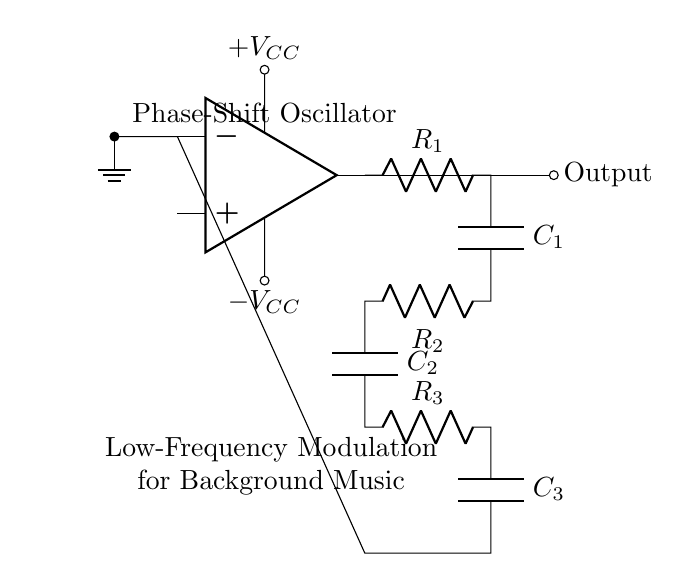What type of oscillator is presented in the circuit? The circuit is labeled as a Phase-Shift Oscillator, which is specifically designed for generating low-frequency waveforms.
Answer: Phase-Shift Oscillator What is the purpose of this oscillator circuit? The circuit is designed for low-frequency modulation in background music tracks, as indicated by the label below the op-amp.
Answer: Low-Frequency Modulation How many resistors are present in the feedback network? By counting the resistors in the circuit, there are three resistors labeled R1, R2, and R3 within the feedback network.
Answer: Three What is the function of the capacitors in the circuit? The capacitors create the phase shift necessary for oscillation in combination with the resistors, which is essential for the feedback loop of the oscillator.
Answer: Phase Shift What does the voltage supply indication suggest about the circuit's operation? The presence of positive and negative voltage supply labels indicates that the op-amp in the oscillator requires dual power supply for proper operation, affecting the performance of the circuit.
Answer: Dual Power Supply How does the output of the oscillator relate to the input? The output is directly connected to the op-amp output, indicating that the oscillator generates a periodic signal based on the conditions set by the feedback network.
Answer: Periodic Signal 